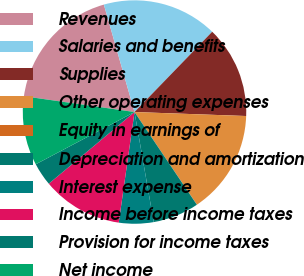Convert chart. <chart><loc_0><loc_0><loc_500><loc_500><pie_chart><fcel>Revenues<fcel>Salaries and benefits<fcel>Supplies<fcel>Other operating expenses<fcel>Equity in earnings of<fcel>Depreciation and amortization<fcel>Interest expense<fcel>Income before income taxes<fcel>Provision for income taxes<fcel>Net income<nl><fcel>18.32%<fcel>16.66%<fcel>13.33%<fcel>14.99%<fcel>0.02%<fcel>6.67%<fcel>5.01%<fcel>11.66%<fcel>3.34%<fcel>10.0%<nl></chart> 